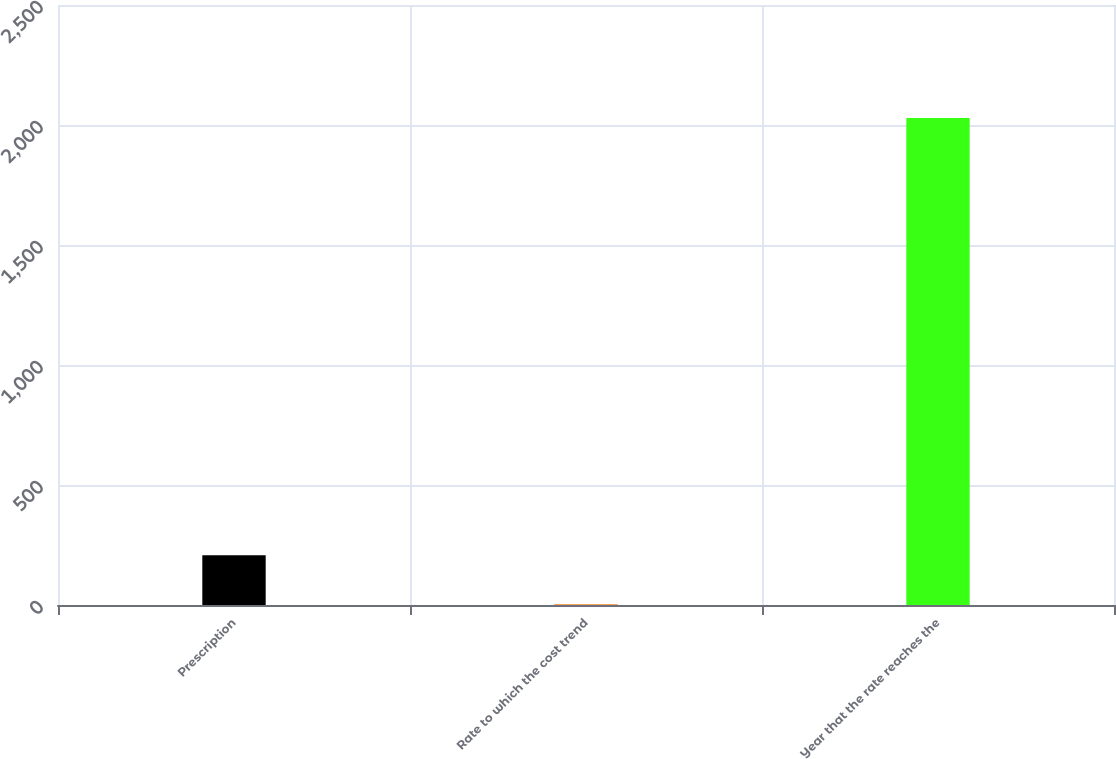<chart> <loc_0><loc_0><loc_500><loc_500><bar_chart><fcel>Prescription<fcel>Rate to which the cost trend<fcel>Year that the rate reaches the<nl><fcel>206.95<fcel>4.5<fcel>2029<nl></chart> 